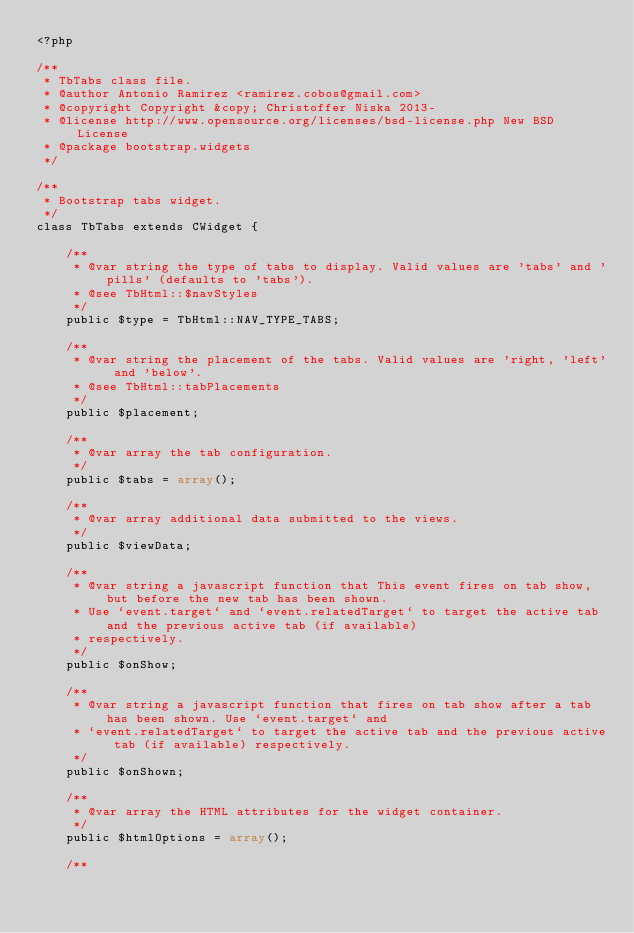Convert code to text. <code><loc_0><loc_0><loc_500><loc_500><_PHP_><?php

/**
 * TbTabs class file.
 * @author Antonio Ramirez <ramirez.cobos@gmail.com>
 * @copyright Copyright &copy; Christoffer Niska 2013-
 * @license http://www.opensource.org/licenses/bsd-license.php New BSD License
 * @package bootstrap.widgets
 */

/**
 * Bootstrap tabs widget.
 */
class TbTabs extends CWidget {

    /**
     * @var string the type of tabs to display. Valid values are 'tabs' and 'pills' (defaults to 'tabs').
     * @see TbHtml::$navStyles
     */
    public $type = TbHtml::NAV_TYPE_TABS;

    /**
     * @var string the placement of the tabs. Valid values are 'right, 'left' and 'below'.
     * @see TbHtml::tabPlacements
     */
    public $placement;

    /**
     * @var array the tab configuration.
     */
    public $tabs = array();

    /**
     * @var array additional data submitted to the views.
     */
    public $viewData;

    /**
     * @var string a javascript function that This event fires on tab show, but before the new tab has been shown.
     * Use `event.target` and `event.relatedTarget` to target the active tab and the previous active tab (if available)
     * respectively.
     */
    public $onShow;

    /**
     * @var string a javascript function that fires on tab show after a tab has been shown. Use `event.target` and
     * `event.relatedTarget` to target the active tab and the previous active tab (if available) respectively.
     */
    public $onShown;

    /**
     * @var array the HTML attributes for the widget container.
     */
    public $htmlOptions = array();

    /**</code> 